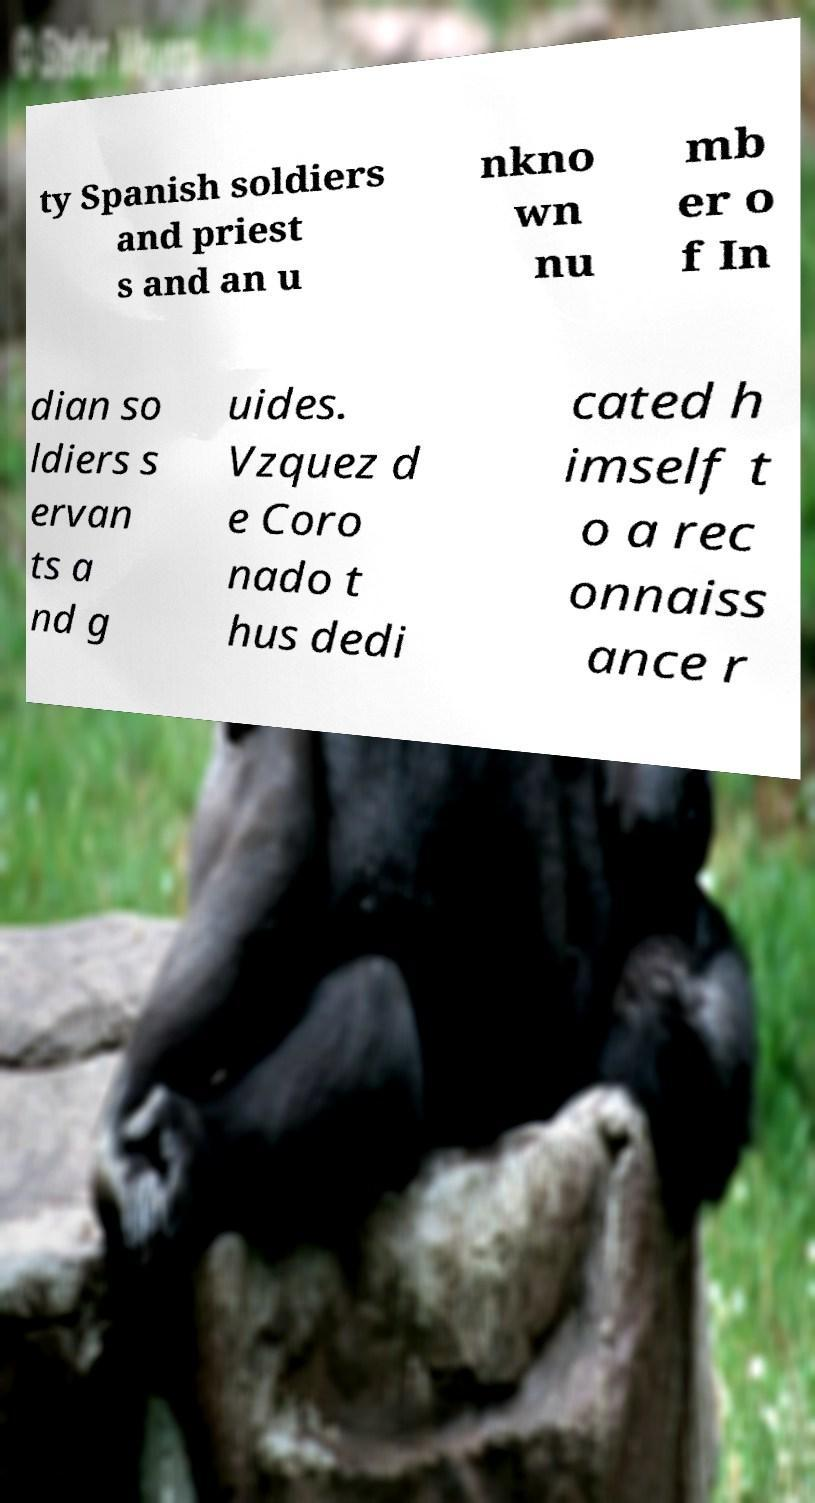Can you accurately transcribe the text from the provided image for me? ty Spanish soldiers and priest s and an u nkno wn nu mb er o f In dian so ldiers s ervan ts a nd g uides. Vzquez d e Coro nado t hus dedi cated h imself t o a rec onnaiss ance r 